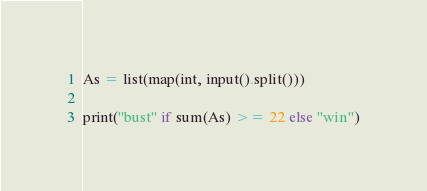<code> <loc_0><loc_0><loc_500><loc_500><_Python_>As = list(map(int, input().split()))

print("bust" if sum(As) >= 22 else "win")</code> 